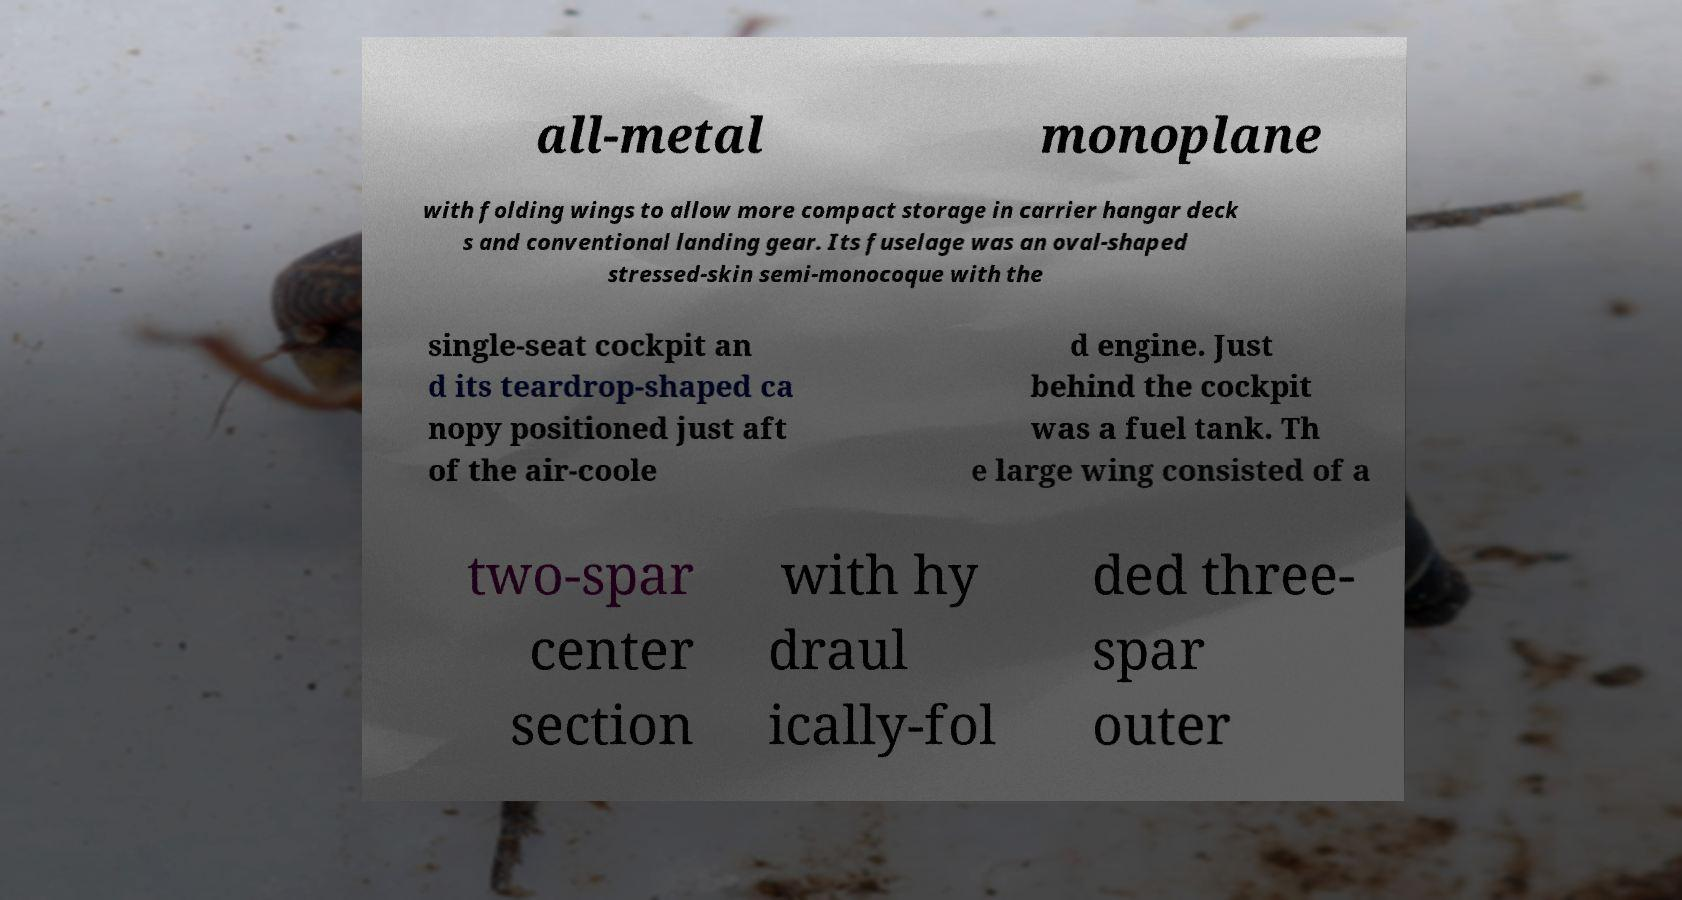What messages or text are displayed in this image? I need them in a readable, typed format. all-metal monoplane with folding wings to allow more compact storage in carrier hangar deck s and conventional landing gear. Its fuselage was an oval-shaped stressed-skin semi-monocoque with the single-seat cockpit an d its teardrop-shaped ca nopy positioned just aft of the air-coole d engine. Just behind the cockpit was a fuel tank. Th e large wing consisted of a two-spar center section with hy draul ically-fol ded three- spar outer 